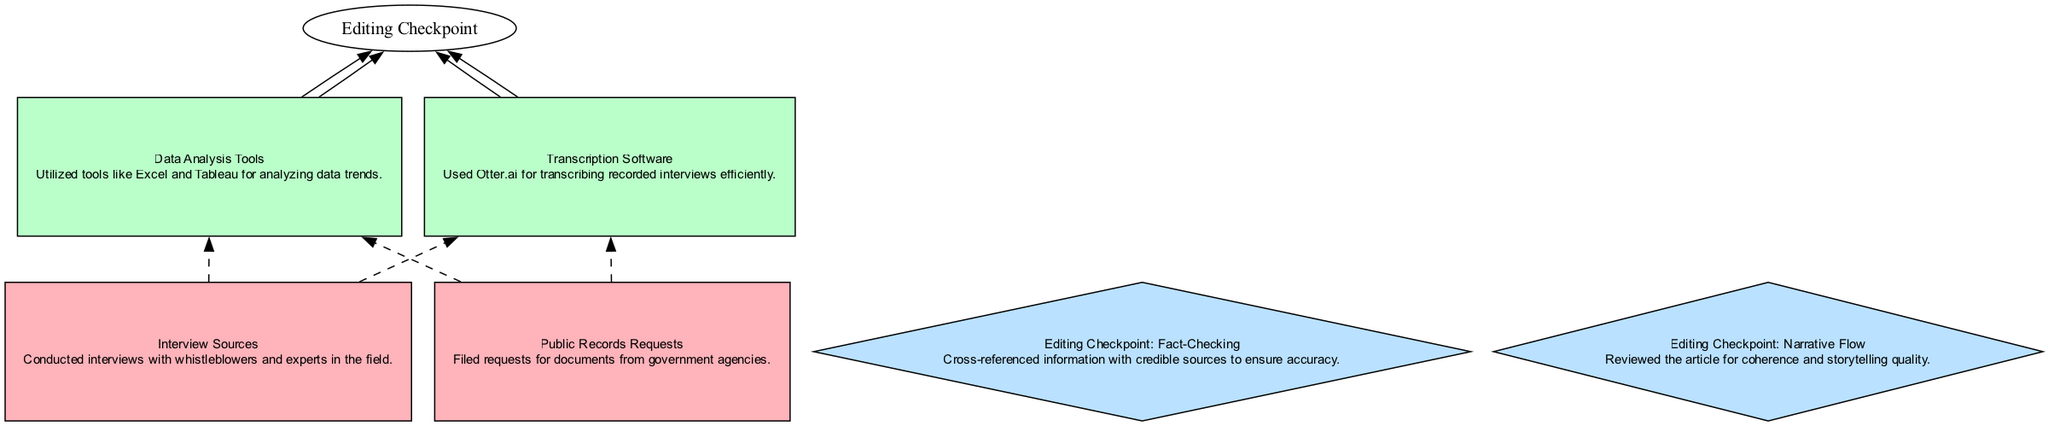What are the types of sources used in the investigative piece? The diagram lists two types of sources: "Interview Sources" and "Public Records Requests." These sources are categorized under the "Source" type and are visually distinguished by their color.
Answer: Interview Sources, Public Records Requests How many tools were utilized in data analysis? The diagram shows two tools: "Data Analysis Tools" and "Transcription Software." Therefore, the total number of tools is counted directly from the visual representation.
Answer: 2 What is the relationship between "Public Records Requests" and "Transcription Software"? In the diagram, "Public Records Requests" connects to the "Transcription Software" via dashed edges. However, this particular source does not directly influence the transcription process since it's not a tool used for transcribing.
Answer: No direct relationship Which editing checkpoint follows the "Transcription Software"? From the diagram structure, the "Transcription Software" leads to two editing checkpoints: "Fact-Checking" and "Narrative Flow." Therefore, they both follow after using the transcription tool.
Answer: Fact-Checking, Narrative Flow What is the primary purpose of the "Data Analysis Tools"? The diagram states that "Data Analysis Tools" are utilized for "analyzing data trends," which is their main purpose as indicated in the description beneath the node.
Answer: Analyzing data trends What is the total number of editing checkpoints illustrated in this diagram? By counting the nodes labeled as editing checkpoints ("Fact-Checking" and "Narrative Flow"), we can easily determine that there are two editing checkpoints present in the diagram.
Answer: 2 Which node is an example of a tool used for recording interviews? The diagram has a specific node labeled "Transcription Software," which indicates that it is used for transcribing recorded interviews, making it a tool that serves this purpose.
Answer: Transcription Software What color represents the sources in the diagram? The color scheme used in the diagram specifies that sources are represented in light red, identified by the color code for the "Source" type in the key.
Answer: Light red 